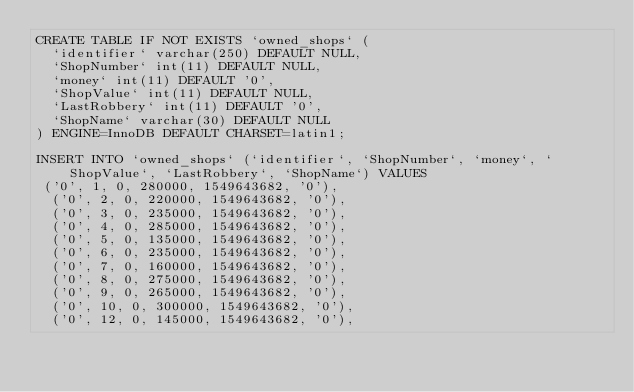Convert code to text. <code><loc_0><loc_0><loc_500><loc_500><_SQL_>CREATE TABLE IF NOT EXISTS `owned_shops` (
  `identifier` varchar(250) DEFAULT NULL,
  `ShopNumber` int(11) DEFAULT NULL,
  `money` int(11) DEFAULT '0',
  `ShopValue` int(11) DEFAULT NULL,
  `LastRobbery` int(11) DEFAULT '0',
  `ShopName` varchar(30) DEFAULT NULL
) ENGINE=InnoDB DEFAULT CHARSET=latin1;

INSERT INTO `owned_shops` (`identifier`, `ShopNumber`, `money`, `ShopValue`, `LastRobbery`, `ShopName`) VALUES
 ('0', 1, 0, 280000, 1549643682, '0'),
  ('0', 2, 0, 220000, 1549643682, '0'),
  ('0', 3, 0, 235000, 1549643682, '0'),
  ('0', 4, 0, 285000, 1549643682, '0'),
  ('0', 5, 0, 135000, 1549643682, '0'),
  ('0', 6, 0, 235000, 1549643682, '0'),
  ('0', 7, 0, 160000, 1549643682, '0'),
  ('0', 8, 0, 275000, 1549643682, '0'),
  ('0', 9, 0, 265000, 1549643682, '0'),
  ('0', 10, 0, 300000, 1549643682, '0'),
  ('0', 12, 0, 145000, 1549643682, '0'),</code> 